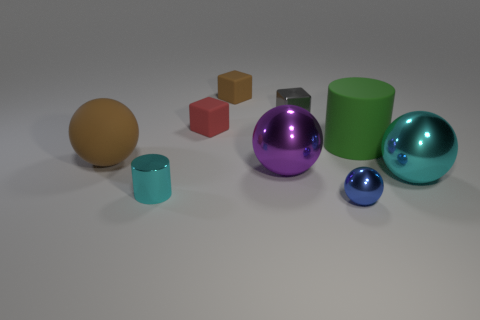There is a tiny shiny thing that is behind the big green cylinder; what color is it?
Keep it short and to the point. Gray. Are there more green matte things behind the big cylinder than tiny blue metallic objects?
Your answer should be compact. No. Is the shape of the large matte thing that is to the left of the brown matte cube the same as  the blue thing?
Your answer should be very brief. Yes. What number of purple objects are either small spheres or large balls?
Provide a succinct answer. 1. Is the number of small red matte objects greater than the number of small purple things?
Your response must be concise. Yes. There is a cylinder that is the same size as the brown sphere; what is its color?
Keep it short and to the point. Green. How many balls are either small cyan shiny things or big shiny things?
Your answer should be compact. 2. There is a green object; is it the same shape as the cyan thing that is left of the cyan ball?
Make the answer very short. Yes. What number of brown blocks have the same size as the red thing?
Your response must be concise. 1. There is a large object on the left side of the large purple thing; does it have the same shape as the brown rubber object that is right of the small cylinder?
Ensure brevity in your answer.  No. 